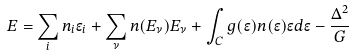<formula> <loc_0><loc_0><loc_500><loc_500>E = \sum _ { i } n _ { i } \epsilon _ { i } + \sum _ { \nu } n ( { E _ { \nu } } ) { E _ { \nu } } + \int _ { C } g ( \epsilon ) n ( \epsilon ) \epsilon d \epsilon - \frac { \Delta ^ { 2 } } { G }</formula> 